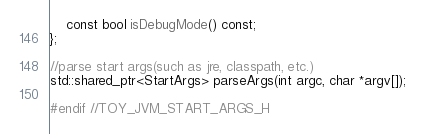<code> <loc_0><loc_0><loc_500><loc_500><_C_>    const bool isDebugMode() const;
};

//parse start args(such as jre, classpath, etc.)
std::shared_ptr<StartArgs> parseArgs(int argc, char *argv[]);

#endif //TOY_JVM_START_ARGS_H
</code> 